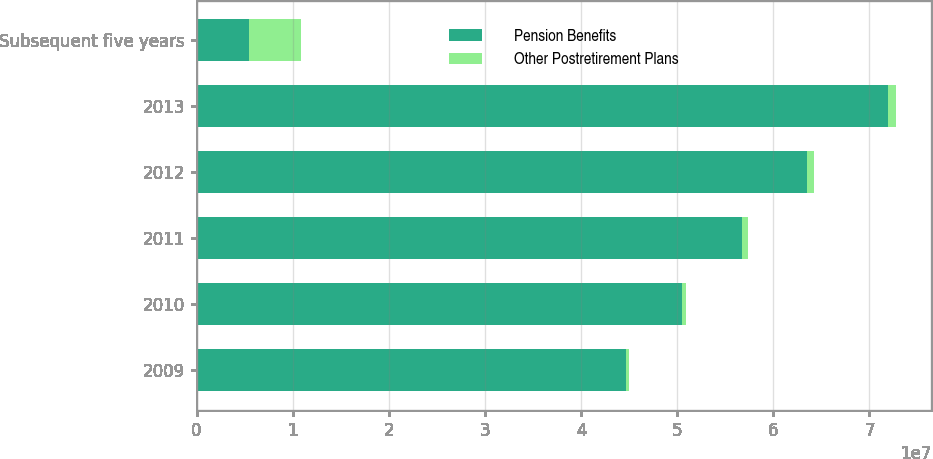Convert chart to OTSL. <chart><loc_0><loc_0><loc_500><loc_500><stacked_bar_chart><ecel><fcel>2009<fcel>2010<fcel>2011<fcel>2012<fcel>2013<fcel>Subsequent five years<nl><fcel>Pension Benefits<fcel>4.4671e+07<fcel>5.0484e+07<fcel>5.6792e+07<fcel>6.35e+07<fcel>7.1919e+07<fcel>5.431e+06<nl><fcel>Other Postretirement Plans<fcel>319000<fcel>434000<fcel>608000<fcel>732000<fcel>863000<fcel>5.431e+06<nl></chart> 